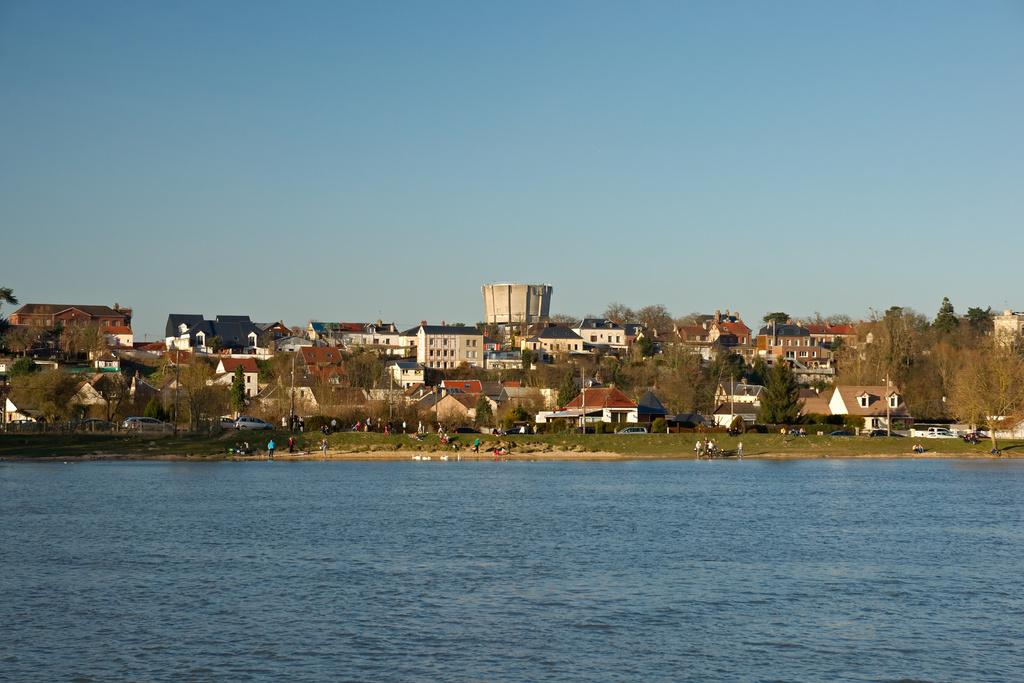What is visible in the image? Water, people, vehicles, buildings, trees, and the sky are visible in the image. Can you describe the people in the image? The image shows people, but their specific actions or characteristics are not mentioned in the facts. What type of vehicles are present in the image? The facts do not specify the type of vehicles present in the image. What is the background of the image like? The background of the image includes buildings, trees, and the sky. What color are the jeans worn by the person in the image? There is no mention of jeans or any specific clothing in the image, so it is not possible to answer this question. 